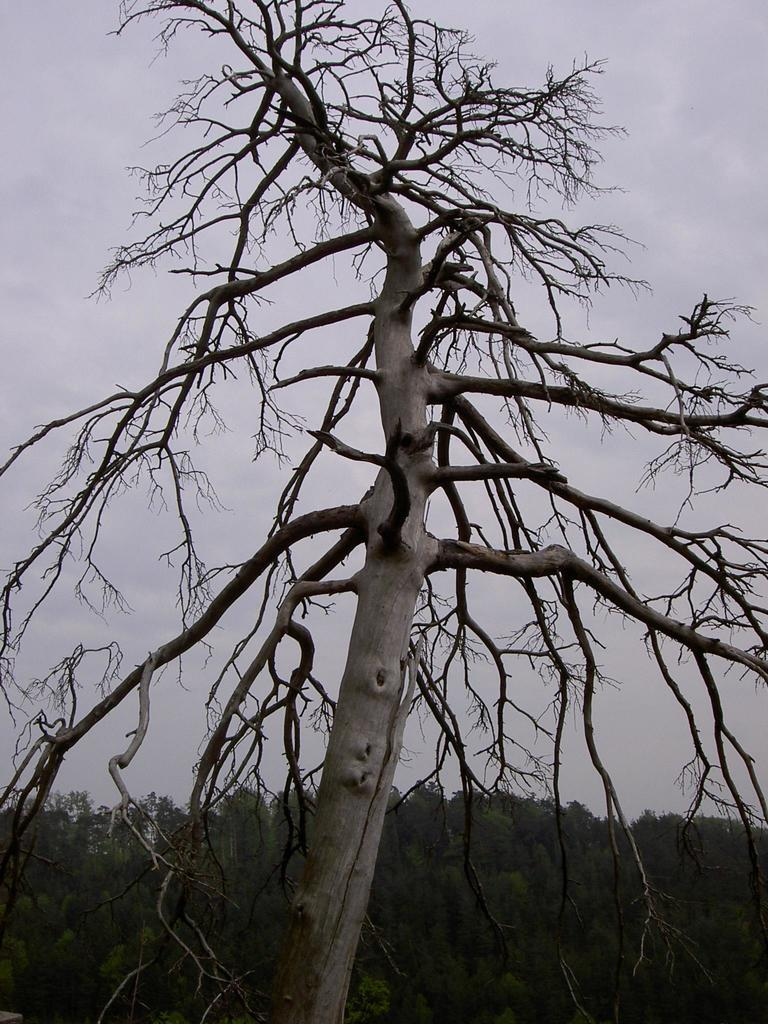What is located in the foreground of the image? There is a tree in the foreground of the image. What is notable about the tree in the foreground? The tree has no leaves. What can be seen in the background of the image? There are many trees visible in the background of the image. What is visible at the top of the image? The sky is visible at the top of the image. How many stomachs can be seen on the tree in the image? There are no stomachs visible on the tree in the image, as trees do not have stomachs. 